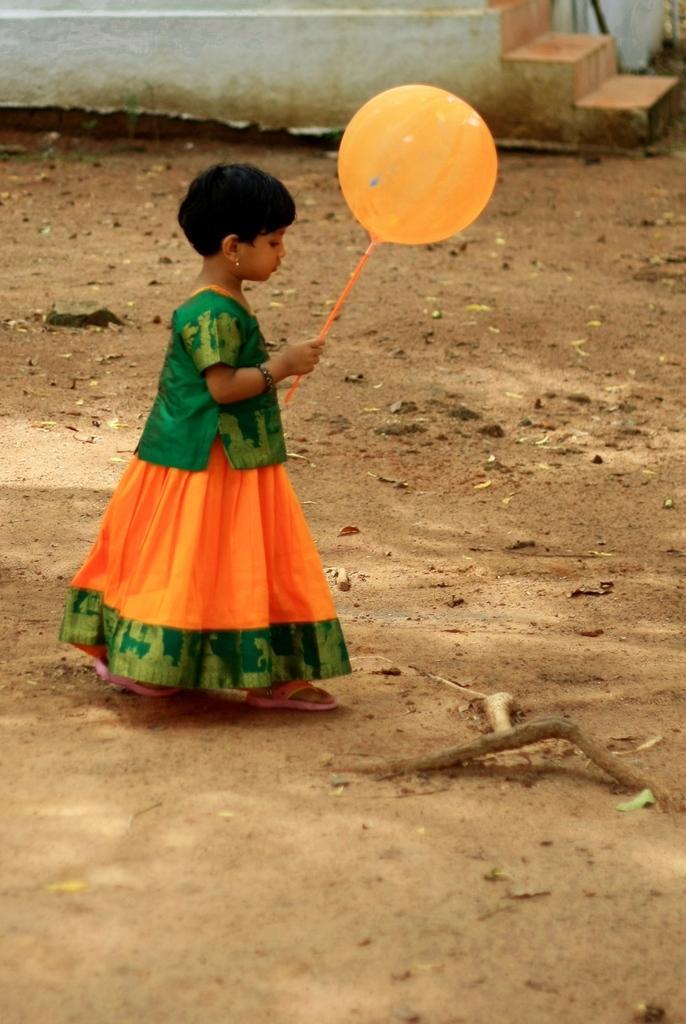In one or two sentences, can you explain what this image depicts? In this image there is a girl walking on the road by holding the balloon. Behind her there are stairs. 